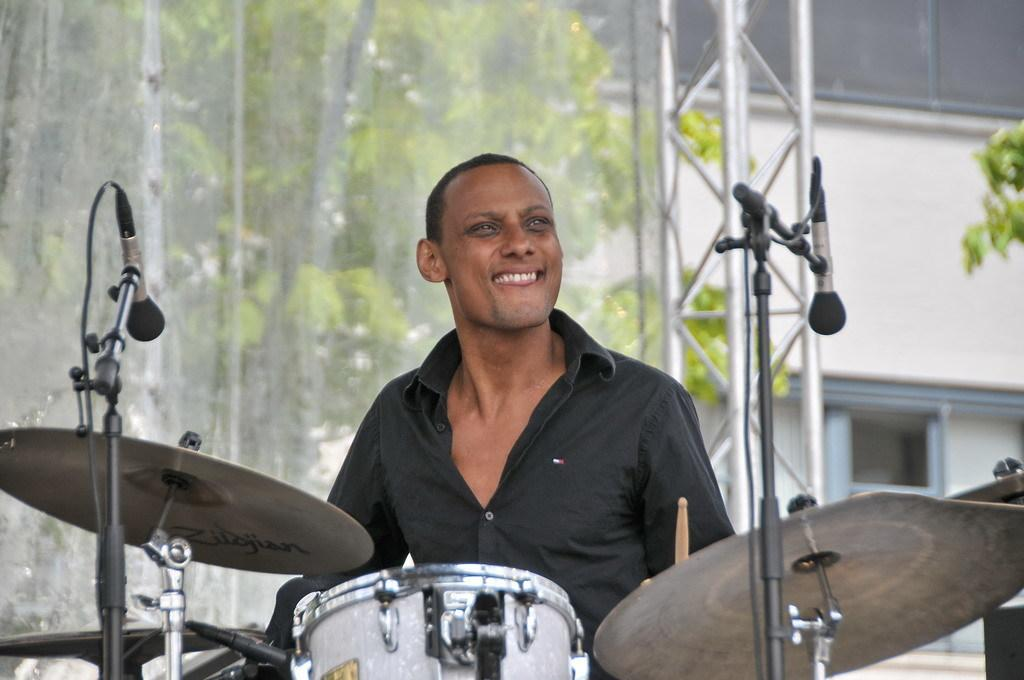What is the man in the image holding? The man is holding sticks in the image. What objects are present in the image that might be used for making music? There are microphones with stands and drums in the image. What can be seen in the background of the image? There is a tree, a pole, and a building with windows visible in the background. What type of yarn is the man using to play the drums in the image? There is no yarn present in the image, and the man is not using any yarn to play the drums. 